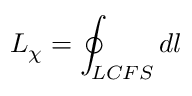<formula> <loc_0><loc_0><loc_500><loc_500>L _ { \chi } = \oint _ { L C F S } d l</formula> 